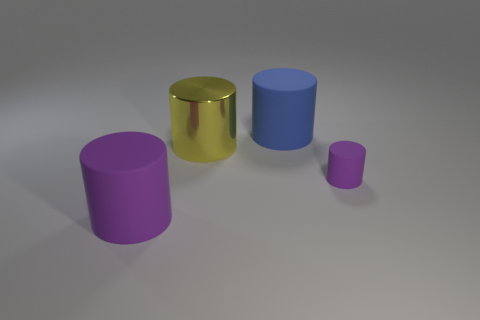Subtract all cyan balls. How many purple cylinders are left? 2 Subtract all metallic cylinders. How many cylinders are left? 3 Subtract all yellow cylinders. How many cylinders are left? 3 Add 4 tiny rubber cylinders. How many objects exist? 8 Subtract 2 cylinders. How many cylinders are left? 2 Subtract all tiny purple objects. Subtract all large yellow cylinders. How many objects are left? 2 Add 2 purple rubber things. How many purple rubber things are left? 4 Add 1 blue objects. How many blue objects exist? 2 Subtract 0 blue balls. How many objects are left? 4 Subtract all blue cylinders. Subtract all green balls. How many cylinders are left? 3 